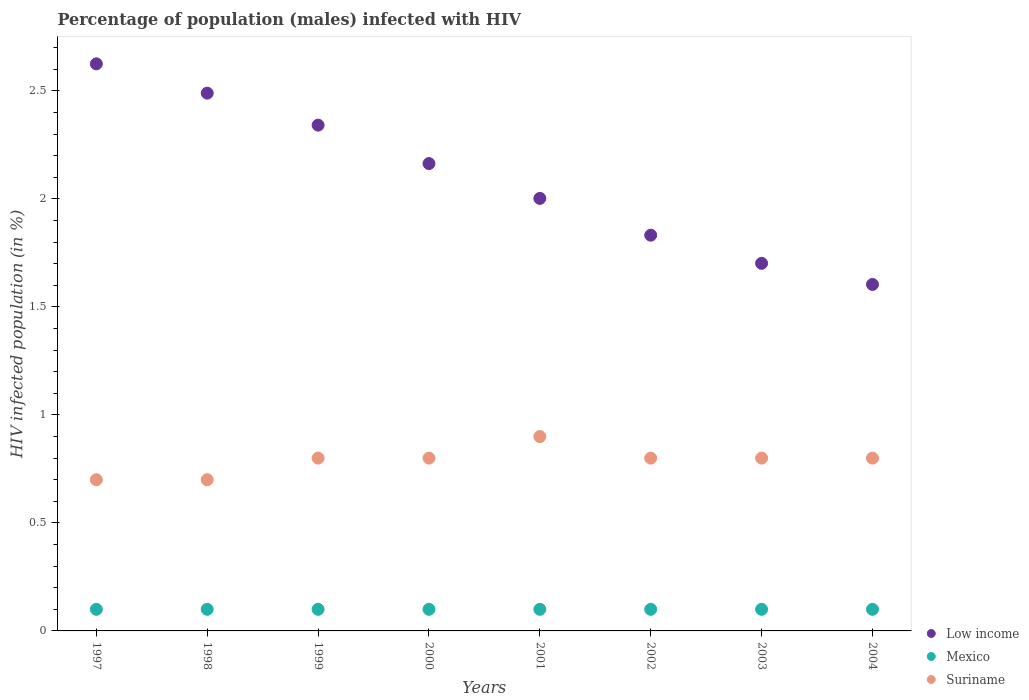What is the percentage of HIV infected male population in Suriname in 1997?
Your response must be concise. 0.7. Across all years, what is the minimum percentage of HIV infected male population in Mexico?
Make the answer very short. 0.1. In which year was the percentage of HIV infected male population in Suriname maximum?
Your answer should be compact. 2001. What is the total percentage of HIV infected male population in Low income in the graph?
Give a very brief answer. 16.76. What is the difference between the percentage of HIV infected male population in Low income in 1999 and the percentage of HIV infected male population in Mexico in 2000?
Give a very brief answer. 2.24. What is the average percentage of HIV infected male population in Suriname per year?
Provide a succinct answer. 0.79. In the year 2000, what is the difference between the percentage of HIV infected male population in Mexico and percentage of HIV infected male population in Suriname?
Ensure brevity in your answer.  -0.7. In how many years, is the percentage of HIV infected male population in Mexico greater than 1.9 %?
Provide a succinct answer. 0. Is the difference between the percentage of HIV infected male population in Mexico in 1998 and 2001 greater than the difference between the percentage of HIV infected male population in Suriname in 1998 and 2001?
Ensure brevity in your answer.  Yes. What is the difference between the highest and the second highest percentage of HIV infected male population in Low income?
Ensure brevity in your answer.  0.14. What is the difference between the highest and the lowest percentage of HIV infected male population in Low income?
Your response must be concise. 1.02. Is it the case that in every year, the sum of the percentage of HIV infected male population in Mexico and percentage of HIV infected male population in Low income  is greater than the percentage of HIV infected male population in Suriname?
Provide a short and direct response. Yes. Does the percentage of HIV infected male population in Low income monotonically increase over the years?
Offer a very short reply. No. How many years are there in the graph?
Keep it short and to the point. 8. What is the difference between two consecutive major ticks on the Y-axis?
Provide a succinct answer. 0.5. Are the values on the major ticks of Y-axis written in scientific E-notation?
Offer a terse response. No. Does the graph contain any zero values?
Ensure brevity in your answer.  No. Where does the legend appear in the graph?
Your answer should be very brief. Bottom right. What is the title of the graph?
Offer a very short reply. Percentage of population (males) infected with HIV. Does "Guinea" appear as one of the legend labels in the graph?
Your response must be concise. No. What is the label or title of the Y-axis?
Ensure brevity in your answer.  HIV infected population (in %). What is the HIV infected population (in %) of Low income in 1997?
Offer a terse response. 2.63. What is the HIV infected population (in %) of Mexico in 1997?
Your answer should be compact. 0.1. What is the HIV infected population (in %) in Low income in 1998?
Ensure brevity in your answer.  2.49. What is the HIV infected population (in %) in Suriname in 1998?
Ensure brevity in your answer.  0.7. What is the HIV infected population (in %) of Low income in 1999?
Provide a short and direct response. 2.34. What is the HIV infected population (in %) of Low income in 2000?
Provide a succinct answer. 2.16. What is the HIV infected population (in %) of Low income in 2001?
Make the answer very short. 2. What is the HIV infected population (in %) of Low income in 2002?
Offer a terse response. 1.83. What is the HIV infected population (in %) in Suriname in 2002?
Ensure brevity in your answer.  0.8. What is the HIV infected population (in %) in Low income in 2003?
Keep it short and to the point. 1.7. What is the HIV infected population (in %) in Low income in 2004?
Provide a succinct answer. 1.6. What is the HIV infected population (in %) of Mexico in 2004?
Offer a terse response. 0.1. Across all years, what is the maximum HIV infected population (in %) in Low income?
Your answer should be very brief. 2.63. Across all years, what is the minimum HIV infected population (in %) of Low income?
Offer a terse response. 1.6. What is the total HIV infected population (in %) of Low income in the graph?
Keep it short and to the point. 16.76. What is the total HIV infected population (in %) of Suriname in the graph?
Your answer should be very brief. 6.3. What is the difference between the HIV infected population (in %) of Low income in 1997 and that in 1998?
Offer a very short reply. 0.14. What is the difference between the HIV infected population (in %) in Mexico in 1997 and that in 1998?
Your answer should be compact. 0. What is the difference between the HIV infected population (in %) in Low income in 1997 and that in 1999?
Your response must be concise. 0.28. What is the difference between the HIV infected population (in %) of Mexico in 1997 and that in 1999?
Make the answer very short. 0. What is the difference between the HIV infected population (in %) of Suriname in 1997 and that in 1999?
Your answer should be compact. -0.1. What is the difference between the HIV infected population (in %) in Low income in 1997 and that in 2000?
Keep it short and to the point. 0.46. What is the difference between the HIV infected population (in %) of Mexico in 1997 and that in 2000?
Make the answer very short. 0. What is the difference between the HIV infected population (in %) of Low income in 1997 and that in 2001?
Ensure brevity in your answer.  0.62. What is the difference between the HIV infected population (in %) of Mexico in 1997 and that in 2001?
Provide a short and direct response. 0. What is the difference between the HIV infected population (in %) of Suriname in 1997 and that in 2001?
Ensure brevity in your answer.  -0.2. What is the difference between the HIV infected population (in %) of Low income in 1997 and that in 2002?
Your answer should be compact. 0.79. What is the difference between the HIV infected population (in %) in Suriname in 1997 and that in 2002?
Make the answer very short. -0.1. What is the difference between the HIV infected population (in %) in Low income in 1997 and that in 2003?
Keep it short and to the point. 0.92. What is the difference between the HIV infected population (in %) in Mexico in 1997 and that in 2003?
Your answer should be very brief. 0. What is the difference between the HIV infected population (in %) of Suriname in 1997 and that in 2003?
Ensure brevity in your answer.  -0.1. What is the difference between the HIV infected population (in %) of Low income in 1997 and that in 2004?
Your answer should be compact. 1.02. What is the difference between the HIV infected population (in %) of Mexico in 1997 and that in 2004?
Give a very brief answer. 0. What is the difference between the HIV infected population (in %) in Suriname in 1997 and that in 2004?
Your answer should be compact. -0.1. What is the difference between the HIV infected population (in %) in Low income in 1998 and that in 1999?
Offer a terse response. 0.15. What is the difference between the HIV infected population (in %) in Suriname in 1998 and that in 1999?
Ensure brevity in your answer.  -0.1. What is the difference between the HIV infected population (in %) in Low income in 1998 and that in 2000?
Your answer should be compact. 0.33. What is the difference between the HIV infected population (in %) of Mexico in 1998 and that in 2000?
Keep it short and to the point. 0. What is the difference between the HIV infected population (in %) in Suriname in 1998 and that in 2000?
Provide a short and direct response. -0.1. What is the difference between the HIV infected population (in %) of Low income in 1998 and that in 2001?
Your response must be concise. 0.49. What is the difference between the HIV infected population (in %) in Mexico in 1998 and that in 2001?
Offer a terse response. 0. What is the difference between the HIV infected population (in %) in Suriname in 1998 and that in 2001?
Your response must be concise. -0.2. What is the difference between the HIV infected population (in %) in Low income in 1998 and that in 2002?
Give a very brief answer. 0.66. What is the difference between the HIV infected population (in %) in Suriname in 1998 and that in 2002?
Provide a short and direct response. -0.1. What is the difference between the HIV infected population (in %) of Low income in 1998 and that in 2003?
Keep it short and to the point. 0.79. What is the difference between the HIV infected population (in %) of Low income in 1998 and that in 2004?
Your answer should be very brief. 0.89. What is the difference between the HIV infected population (in %) in Mexico in 1998 and that in 2004?
Offer a very short reply. 0. What is the difference between the HIV infected population (in %) in Low income in 1999 and that in 2000?
Offer a very short reply. 0.18. What is the difference between the HIV infected population (in %) of Mexico in 1999 and that in 2000?
Keep it short and to the point. 0. What is the difference between the HIV infected population (in %) in Suriname in 1999 and that in 2000?
Your answer should be compact. 0. What is the difference between the HIV infected population (in %) of Low income in 1999 and that in 2001?
Your answer should be compact. 0.34. What is the difference between the HIV infected population (in %) in Mexico in 1999 and that in 2001?
Ensure brevity in your answer.  0. What is the difference between the HIV infected population (in %) in Suriname in 1999 and that in 2001?
Offer a terse response. -0.1. What is the difference between the HIV infected population (in %) of Low income in 1999 and that in 2002?
Make the answer very short. 0.51. What is the difference between the HIV infected population (in %) of Mexico in 1999 and that in 2002?
Provide a short and direct response. 0. What is the difference between the HIV infected population (in %) of Suriname in 1999 and that in 2002?
Keep it short and to the point. 0. What is the difference between the HIV infected population (in %) of Low income in 1999 and that in 2003?
Offer a very short reply. 0.64. What is the difference between the HIV infected population (in %) in Low income in 1999 and that in 2004?
Offer a very short reply. 0.74. What is the difference between the HIV infected population (in %) in Mexico in 1999 and that in 2004?
Your answer should be compact. 0. What is the difference between the HIV infected population (in %) in Suriname in 1999 and that in 2004?
Provide a succinct answer. 0. What is the difference between the HIV infected population (in %) of Low income in 2000 and that in 2001?
Your response must be concise. 0.16. What is the difference between the HIV infected population (in %) of Suriname in 2000 and that in 2001?
Offer a terse response. -0.1. What is the difference between the HIV infected population (in %) of Low income in 2000 and that in 2002?
Provide a short and direct response. 0.33. What is the difference between the HIV infected population (in %) in Low income in 2000 and that in 2003?
Provide a succinct answer. 0.46. What is the difference between the HIV infected population (in %) in Mexico in 2000 and that in 2003?
Your response must be concise. 0. What is the difference between the HIV infected population (in %) of Suriname in 2000 and that in 2003?
Your answer should be very brief. 0. What is the difference between the HIV infected population (in %) in Low income in 2000 and that in 2004?
Your answer should be compact. 0.56. What is the difference between the HIV infected population (in %) in Low income in 2001 and that in 2002?
Give a very brief answer. 0.17. What is the difference between the HIV infected population (in %) of Low income in 2001 and that in 2003?
Ensure brevity in your answer.  0.3. What is the difference between the HIV infected population (in %) of Low income in 2001 and that in 2004?
Keep it short and to the point. 0.4. What is the difference between the HIV infected population (in %) in Mexico in 2001 and that in 2004?
Make the answer very short. 0. What is the difference between the HIV infected population (in %) in Suriname in 2001 and that in 2004?
Provide a short and direct response. 0.1. What is the difference between the HIV infected population (in %) of Low income in 2002 and that in 2003?
Make the answer very short. 0.13. What is the difference between the HIV infected population (in %) in Mexico in 2002 and that in 2003?
Your answer should be compact. 0. What is the difference between the HIV infected population (in %) of Suriname in 2002 and that in 2003?
Your answer should be very brief. 0. What is the difference between the HIV infected population (in %) in Low income in 2002 and that in 2004?
Your response must be concise. 0.23. What is the difference between the HIV infected population (in %) of Suriname in 2002 and that in 2004?
Provide a short and direct response. 0. What is the difference between the HIV infected population (in %) in Low income in 2003 and that in 2004?
Your answer should be compact. 0.1. What is the difference between the HIV infected population (in %) of Low income in 1997 and the HIV infected population (in %) of Mexico in 1998?
Offer a terse response. 2.53. What is the difference between the HIV infected population (in %) of Low income in 1997 and the HIV infected population (in %) of Suriname in 1998?
Offer a very short reply. 1.93. What is the difference between the HIV infected population (in %) in Low income in 1997 and the HIV infected population (in %) in Mexico in 1999?
Your answer should be very brief. 2.53. What is the difference between the HIV infected population (in %) of Low income in 1997 and the HIV infected population (in %) of Suriname in 1999?
Your answer should be compact. 1.83. What is the difference between the HIV infected population (in %) in Low income in 1997 and the HIV infected population (in %) in Mexico in 2000?
Ensure brevity in your answer.  2.53. What is the difference between the HIV infected population (in %) in Low income in 1997 and the HIV infected population (in %) in Suriname in 2000?
Offer a terse response. 1.83. What is the difference between the HIV infected population (in %) of Mexico in 1997 and the HIV infected population (in %) of Suriname in 2000?
Give a very brief answer. -0.7. What is the difference between the HIV infected population (in %) of Low income in 1997 and the HIV infected population (in %) of Mexico in 2001?
Your answer should be compact. 2.53. What is the difference between the HIV infected population (in %) of Low income in 1997 and the HIV infected population (in %) of Suriname in 2001?
Make the answer very short. 1.73. What is the difference between the HIV infected population (in %) of Mexico in 1997 and the HIV infected population (in %) of Suriname in 2001?
Provide a succinct answer. -0.8. What is the difference between the HIV infected population (in %) of Low income in 1997 and the HIV infected population (in %) of Mexico in 2002?
Ensure brevity in your answer.  2.53. What is the difference between the HIV infected population (in %) of Low income in 1997 and the HIV infected population (in %) of Suriname in 2002?
Your answer should be very brief. 1.83. What is the difference between the HIV infected population (in %) in Mexico in 1997 and the HIV infected population (in %) in Suriname in 2002?
Provide a short and direct response. -0.7. What is the difference between the HIV infected population (in %) of Low income in 1997 and the HIV infected population (in %) of Mexico in 2003?
Give a very brief answer. 2.53. What is the difference between the HIV infected population (in %) of Low income in 1997 and the HIV infected population (in %) of Suriname in 2003?
Offer a terse response. 1.83. What is the difference between the HIV infected population (in %) of Mexico in 1997 and the HIV infected population (in %) of Suriname in 2003?
Provide a short and direct response. -0.7. What is the difference between the HIV infected population (in %) of Low income in 1997 and the HIV infected population (in %) of Mexico in 2004?
Offer a terse response. 2.53. What is the difference between the HIV infected population (in %) of Low income in 1997 and the HIV infected population (in %) of Suriname in 2004?
Keep it short and to the point. 1.83. What is the difference between the HIV infected population (in %) of Mexico in 1997 and the HIV infected population (in %) of Suriname in 2004?
Offer a terse response. -0.7. What is the difference between the HIV infected population (in %) of Low income in 1998 and the HIV infected population (in %) of Mexico in 1999?
Make the answer very short. 2.39. What is the difference between the HIV infected population (in %) of Low income in 1998 and the HIV infected population (in %) of Suriname in 1999?
Offer a terse response. 1.69. What is the difference between the HIV infected population (in %) of Mexico in 1998 and the HIV infected population (in %) of Suriname in 1999?
Ensure brevity in your answer.  -0.7. What is the difference between the HIV infected population (in %) in Low income in 1998 and the HIV infected population (in %) in Mexico in 2000?
Provide a short and direct response. 2.39. What is the difference between the HIV infected population (in %) in Low income in 1998 and the HIV infected population (in %) in Suriname in 2000?
Make the answer very short. 1.69. What is the difference between the HIV infected population (in %) of Low income in 1998 and the HIV infected population (in %) of Mexico in 2001?
Give a very brief answer. 2.39. What is the difference between the HIV infected population (in %) in Low income in 1998 and the HIV infected population (in %) in Suriname in 2001?
Offer a terse response. 1.59. What is the difference between the HIV infected population (in %) in Low income in 1998 and the HIV infected population (in %) in Mexico in 2002?
Offer a terse response. 2.39. What is the difference between the HIV infected population (in %) in Low income in 1998 and the HIV infected population (in %) in Suriname in 2002?
Ensure brevity in your answer.  1.69. What is the difference between the HIV infected population (in %) in Mexico in 1998 and the HIV infected population (in %) in Suriname in 2002?
Your answer should be compact. -0.7. What is the difference between the HIV infected population (in %) in Low income in 1998 and the HIV infected population (in %) in Mexico in 2003?
Offer a terse response. 2.39. What is the difference between the HIV infected population (in %) in Low income in 1998 and the HIV infected population (in %) in Suriname in 2003?
Make the answer very short. 1.69. What is the difference between the HIV infected population (in %) of Low income in 1998 and the HIV infected population (in %) of Mexico in 2004?
Make the answer very short. 2.39. What is the difference between the HIV infected population (in %) of Low income in 1998 and the HIV infected population (in %) of Suriname in 2004?
Provide a succinct answer. 1.69. What is the difference between the HIV infected population (in %) of Low income in 1999 and the HIV infected population (in %) of Mexico in 2000?
Your answer should be compact. 2.24. What is the difference between the HIV infected population (in %) of Low income in 1999 and the HIV infected population (in %) of Suriname in 2000?
Your answer should be very brief. 1.54. What is the difference between the HIV infected population (in %) of Low income in 1999 and the HIV infected population (in %) of Mexico in 2001?
Offer a terse response. 2.24. What is the difference between the HIV infected population (in %) in Low income in 1999 and the HIV infected population (in %) in Suriname in 2001?
Give a very brief answer. 1.44. What is the difference between the HIV infected population (in %) of Low income in 1999 and the HIV infected population (in %) of Mexico in 2002?
Your response must be concise. 2.24. What is the difference between the HIV infected population (in %) of Low income in 1999 and the HIV infected population (in %) of Suriname in 2002?
Keep it short and to the point. 1.54. What is the difference between the HIV infected population (in %) in Low income in 1999 and the HIV infected population (in %) in Mexico in 2003?
Your answer should be compact. 2.24. What is the difference between the HIV infected population (in %) in Low income in 1999 and the HIV infected population (in %) in Suriname in 2003?
Give a very brief answer. 1.54. What is the difference between the HIV infected population (in %) in Mexico in 1999 and the HIV infected population (in %) in Suriname in 2003?
Keep it short and to the point. -0.7. What is the difference between the HIV infected population (in %) in Low income in 1999 and the HIV infected population (in %) in Mexico in 2004?
Give a very brief answer. 2.24. What is the difference between the HIV infected population (in %) in Low income in 1999 and the HIV infected population (in %) in Suriname in 2004?
Make the answer very short. 1.54. What is the difference between the HIV infected population (in %) of Low income in 2000 and the HIV infected population (in %) of Mexico in 2001?
Give a very brief answer. 2.06. What is the difference between the HIV infected population (in %) of Low income in 2000 and the HIV infected population (in %) of Suriname in 2001?
Provide a succinct answer. 1.26. What is the difference between the HIV infected population (in %) of Mexico in 2000 and the HIV infected population (in %) of Suriname in 2001?
Make the answer very short. -0.8. What is the difference between the HIV infected population (in %) of Low income in 2000 and the HIV infected population (in %) of Mexico in 2002?
Offer a terse response. 2.06. What is the difference between the HIV infected population (in %) of Low income in 2000 and the HIV infected population (in %) of Suriname in 2002?
Your answer should be compact. 1.36. What is the difference between the HIV infected population (in %) of Low income in 2000 and the HIV infected population (in %) of Mexico in 2003?
Keep it short and to the point. 2.06. What is the difference between the HIV infected population (in %) of Low income in 2000 and the HIV infected population (in %) of Suriname in 2003?
Offer a very short reply. 1.36. What is the difference between the HIV infected population (in %) of Low income in 2000 and the HIV infected population (in %) of Mexico in 2004?
Provide a short and direct response. 2.06. What is the difference between the HIV infected population (in %) in Low income in 2000 and the HIV infected population (in %) in Suriname in 2004?
Ensure brevity in your answer.  1.36. What is the difference between the HIV infected population (in %) of Low income in 2001 and the HIV infected population (in %) of Mexico in 2002?
Keep it short and to the point. 1.9. What is the difference between the HIV infected population (in %) in Low income in 2001 and the HIV infected population (in %) in Suriname in 2002?
Your response must be concise. 1.2. What is the difference between the HIV infected population (in %) of Mexico in 2001 and the HIV infected population (in %) of Suriname in 2002?
Your response must be concise. -0.7. What is the difference between the HIV infected population (in %) in Low income in 2001 and the HIV infected population (in %) in Mexico in 2003?
Offer a very short reply. 1.9. What is the difference between the HIV infected population (in %) in Low income in 2001 and the HIV infected population (in %) in Suriname in 2003?
Provide a short and direct response. 1.2. What is the difference between the HIV infected population (in %) in Low income in 2001 and the HIV infected population (in %) in Mexico in 2004?
Provide a short and direct response. 1.9. What is the difference between the HIV infected population (in %) in Low income in 2001 and the HIV infected population (in %) in Suriname in 2004?
Your answer should be compact. 1.2. What is the difference between the HIV infected population (in %) of Low income in 2002 and the HIV infected population (in %) of Mexico in 2003?
Give a very brief answer. 1.73. What is the difference between the HIV infected population (in %) of Low income in 2002 and the HIV infected population (in %) of Suriname in 2003?
Provide a short and direct response. 1.03. What is the difference between the HIV infected population (in %) of Low income in 2002 and the HIV infected population (in %) of Mexico in 2004?
Ensure brevity in your answer.  1.73. What is the difference between the HIV infected population (in %) in Low income in 2002 and the HIV infected population (in %) in Suriname in 2004?
Keep it short and to the point. 1.03. What is the difference between the HIV infected population (in %) of Low income in 2003 and the HIV infected population (in %) of Mexico in 2004?
Your response must be concise. 1.6. What is the difference between the HIV infected population (in %) in Low income in 2003 and the HIV infected population (in %) in Suriname in 2004?
Offer a very short reply. 0.9. What is the average HIV infected population (in %) in Low income per year?
Your answer should be compact. 2.1. What is the average HIV infected population (in %) of Mexico per year?
Keep it short and to the point. 0.1. What is the average HIV infected population (in %) in Suriname per year?
Offer a very short reply. 0.79. In the year 1997, what is the difference between the HIV infected population (in %) of Low income and HIV infected population (in %) of Mexico?
Your response must be concise. 2.53. In the year 1997, what is the difference between the HIV infected population (in %) in Low income and HIV infected population (in %) in Suriname?
Give a very brief answer. 1.93. In the year 1998, what is the difference between the HIV infected population (in %) of Low income and HIV infected population (in %) of Mexico?
Your answer should be very brief. 2.39. In the year 1998, what is the difference between the HIV infected population (in %) in Low income and HIV infected population (in %) in Suriname?
Your answer should be very brief. 1.79. In the year 1999, what is the difference between the HIV infected population (in %) in Low income and HIV infected population (in %) in Mexico?
Your answer should be very brief. 2.24. In the year 1999, what is the difference between the HIV infected population (in %) in Low income and HIV infected population (in %) in Suriname?
Your response must be concise. 1.54. In the year 1999, what is the difference between the HIV infected population (in %) of Mexico and HIV infected population (in %) of Suriname?
Make the answer very short. -0.7. In the year 2000, what is the difference between the HIV infected population (in %) in Low income and HIV infected population (in %) in Mexico?
Your response must be concise. 2.06. In the year 2000, what is the difference between the HIV infected population (in %) of Low income and HIV infected population (in %) of Suriname?
Your answer should be compact. 1.36. In the year 2001, what is the difference between the HIV infected population (in %) in Low income and HIV infected population (in %) in Mexico?
Give a very brief answer. 1.9. In the year 2001, what is the difference between the HIV infected population (in %) in Low income and HIV infected population (in %) in Suriname?
Your answer should be very brief. 1.1. In the year 2002, what is the difference between the HIV infected population (in %) in Low income and HIV infected population (in %) in Mexico?
Offer a very short reply. 1.73. In the year 2002, what is the difference between the HIV infected population (in %) in Low income and HIV infected population (in %) in Suriname?
Offer a terse response. 1.03. In the year 2003, what is the difference between the HIV infected population (in %) in Low income and HIV infected population (in %) in Mexico?
Provide a succinct answer. 1.6. In the year 2003, what is the difference between the HIV infected population (in %) of Low income and HIV infected population (in %) of Suriname?
Make the answer very short. 0.9. In the year 2004, what is the difference between the HIV infected population (in %) of Low income and HIV infected population (in %) of Mexico?
Provide a succinct answer. 1.5. In the year 2004, what is the difference between the HIV infected population (in %) in Low income and HIV infected population (in %) in Suriname?
Keep it short and to the point. 0.8. What is the ratio of the HIV infected population (in %) in Low income in 1997 to that in 1998?
Provide a short and direct response. 1.05. What is the ratio of the HIV infected population (in %) of Low income in 1997 to that in 1999?
Offer a very short reply. 1.12. What is the ratio of the HIV infected population (in %) in Low income in 1997 to that in 2000?
Your answer should be compact. 1.21. What is the ratio of the HIV infected population (in %) in Mexico in 1997 to that in 2000?
Give a very brief answer. 1. What is the ratio of the HIV infected population (in %) in Low income in 1997 to that in 2001?
Provide a succinct answer. 1.31. What is the ratio of the HIV infected population (in %) of Suriname in 1997 to that in 2001?
Your answer should be very brief. 0.78. What is the ratio of the HIV infected population (in %) in Low income in 1997 to that in 2002?
Your response must be concise. 1.43. What is the ratio of the HIV infected population (in %) of Low income in 1997 to that in 2003?
Ensure brevity in your answer.  1.54. What is the ratio of the HIV infected population (in %) in Suriname in 1997 to that in 2003?
Provide a succinct answer. 0.88. What is the ratio of the HIV infected population (in %) of Low income in 1997 to that in 2004?
Provide a succinct answer. 1.64. What is the ratio of the HIV infected population (in %) of Mexico in 1997 to that in 2004?
Your answer should be very brief. 1. What is the ratio of the HIV infected population (in %) of Suriname in 1997 to that in 2004?
Offer a terse response. 0.88. What is the ratio of the HIV infected population (in %) of Low income in 1998 to that in 1999?
Your answer should be compact. 1.06. What is the ratio of the HIV infected population (in %) in Suriname in 1998 to that in 1999?
Your answer should be compact. 0.88. What is the ratio of the HIV infected population (in %) in Low income in 1998 to that in 2000?
Provide a succinct answer. 1.15. What is the ratio of the HIV infected population (in %) of Mexico in 1998 to that in 2000?
Your answer should be compact. 1. What is the ratio of the HIV infected population (in %) of Suriname in 1998 to that in 2000?
Provide a succinct answer. 0.88. What is the ratio of the HIV infected population (in %) in Low income in 1998 to that in 2001?
Provide a short and direct response. 1.24. What is the ratio of the HIV infected population (in %) in Suriname in 1998 to that in 2001?
Your answer should be compact. 0.78. What is the ratio of the HIV infected population (in %) in Low income in 1998 to that in 2002?
Give a very brief answer. 1.36. What is the ratio of the HIV infected population (in %) of Mexico in 1998 to that in 2002?
Offer a terse response. 1. What is the ratio of the HIV infected population (in %) in Suriname in 1998 to that in 2002?
Ensure brevity in your answer.  0.88. What is the ratio of the HIV infected population (in %) in Low income in 1998 to that in 2003?
Keep it short and to the point. 1.46. What is the ratio of the HIV infected population (in %) in Low income in 1998 to that in 2004?
Give a very brief answer. 1.55. What is the ratio of the HIV infected population (in %) in Low income in 1999 to that in 2000?
Give a very brief answer. 1.08. What is the ratio of the HIV infected population (in %) of Suriname in 1999 to that in 2000?
Your answer should be very brief. 1. What is the ratio of the HIV infected population (in %) of Low income in 1999 to that in 2001?
Offer a very short reply. 1.17. What is the ratio of the HIV infected population (in %) of Suriname in 1999 to that in 2001?
Give a very brief answer. 0.89. What is the ratio of the HIV infected population (in %) of Low income in 1999 to that in 2002?
Provide a succinct answer. 1.28. What is the ratio of the HIV infected population (in %) in Suriname in 1999 to that in 2002?
Make the answer very short. 1. What is the ratio of the HIV infected population (in %) of Low income in 1999 to that in 2003?
Offer a very short reply. 1.38. What is the ratio of the HIV infected population (in %) of Mexico in 1999 to that in 2003?
Give a very brief answer. 1. What is the ratio of the HIV infected population (in %) of Suriname in 1999 to that in 2003?
Offer a very short reply. 1. What is the ratio of the HIV infected population (in %) of Low income in 1999 to that in 2004?
Your answer should be compact. 1.46. What is the ratio of the HIV infected population (in %) in Suriname in 1999 to that in 2004?
Your response must be concise. 1. What is the ratio of the HIV infected population (in %) of Low income in 2000 to that in 2001?
Provide a short and direct response. 1.08. What is the ratio of the HIV infected population (in %) of Mexico in 2000 to that in 2001?
Your answer should be very brief. 1. What is the ratio of the HIV infected population (in %) in Suriname in 2000 to that in 2001?
Provide a short and direct response. 0.89. What is the ratio of the HIV infected population (in %) of Low income in 2000 to that in 2002?
Offer a very short reply. 1.18. What is the ratio of the HIV infected population (in %) of Suriname in 2000 to that in 2002?
Your answer should be compact. 1. What is the ratio of the HIV infected population (in %) of Low income in 2000 to that in 2003?
Offer a terse response. 1.27. What is the ratio of the HIV infected population (in %) of Mexico in 2000 to that in 2003?
Ensure brevity in your answer.  1. What is the ratio of the HIV infected population (in %) of Low income in 2000 to that in 2004?
Give a very brief answer. 1.35. What is the ratio of the HIV infected population (in %) of Mexico in 2000 to that in 2004?
Keep it short and to the point. 1. What is the ratio of the HIV infected population (in %) of Suriname in 2000 to that in 2004?
Your response must be concise. 1. What is the ratio of the HIV infected population (in %) of Low income in 2001 to that in 2002?
Provide a succinct answer. 1.09. What is the ratio of the HIV infected population (in %) in Mexico in 2001 to that in 2002?
Your answer should be compact. 1. What is the ratio of the HIV infected population (in %) in Low income in 2001 to that in 2003?
Offer a terse response. 1.18. What is the ratio of the HIV infected population (in %) in Low income in 2001 to that in 2004?
Offer a very short reply. 1.25. What is the ratio of the HIV infected population (in %) in Low income in 2002 to that in 2003?
Your answer should be very brief. 1.08. What is the ratio of the HIV infected population (in %) in Suriname in 2002 to that in 2003?
Your response must be concise. 1. What is the ratio of the HIV infected population (in %) of Low income in 2002 to that in 2004?
Provide a short and direct response. 1.14. What is the ratio of the HIV infected population (in %) of Mexico in 2002 to that in 2004?
Your answer should be compact. 1. What is the ratio of the HIV infected population (in %) in Low income in 2003 to that in 2004?
Your response must be concise. 1.06. What is the ratio of the HIV infected population (in %) of Mexico in 2003 to that in 2004?
Your answer should be compact. 1. What is the ratio of the HIV infected population (in %) of Suriname in 2003 to that in 2004?
Give a very brief answer. 1. What is the difference between the highest and the second highest HIV infected population (in %) in Low income?
Make the answer very short. 0.14. What is the difference between the highest and the second highest HIV infected population (in %) of Mexico?
Your response must be concise. 0. What is the difference between the highest and the lowest HIV infected population (in %) of Low income?
Offer a terse response. 1.02. What is the difference between the highest and the lowest HIV infected population (in %) of Mexico?
Make the answer very short. 0. What is the difference between the highest and the lowest HIV infected population (in %) in Suriname?
Offer a very short reply. 0.2. 